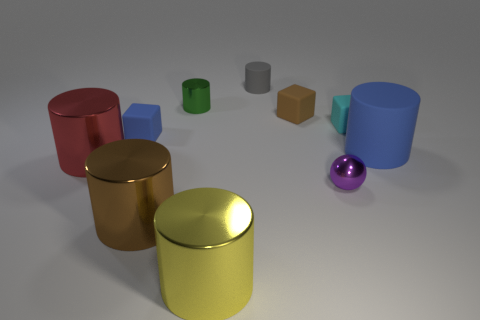There is a rubber cylinder that is behind the tiny blue matte block; what color is it?
Ensure brevity in your answer.  Gray. What number of blue things are either tiny matte blocks or large rubber objects?
Provide a succinct answer. 2. What is the color of the large rubber cylinder?
Make the answer very short. Blue. Is there anything else that has the same material as the sphere?
Make the answer very short. Yes. Are there fewer large red metallic cylinders on the left side of the small gray rubber thing than metallic cylinders behind the large blue cylinder?
Provide a succinct answer. No. The tiny object that is right of the large brown cylinder and left of the yellow thing has what shape?
Make the answer very short. Cylinder. What number of other small brown things have the same shape as the tiny brown thing?
Give a very brief answer. 0. The sphere that is made of the same material as the red object is what size?
Provide a succinct answer. Small. What number of purple metal cubes have the same size as the yellow metal thing?
Your answer should be compact. 0. What size is the thing that is the same color as the big rubber cylinder?
Your response must be concise. Small. 